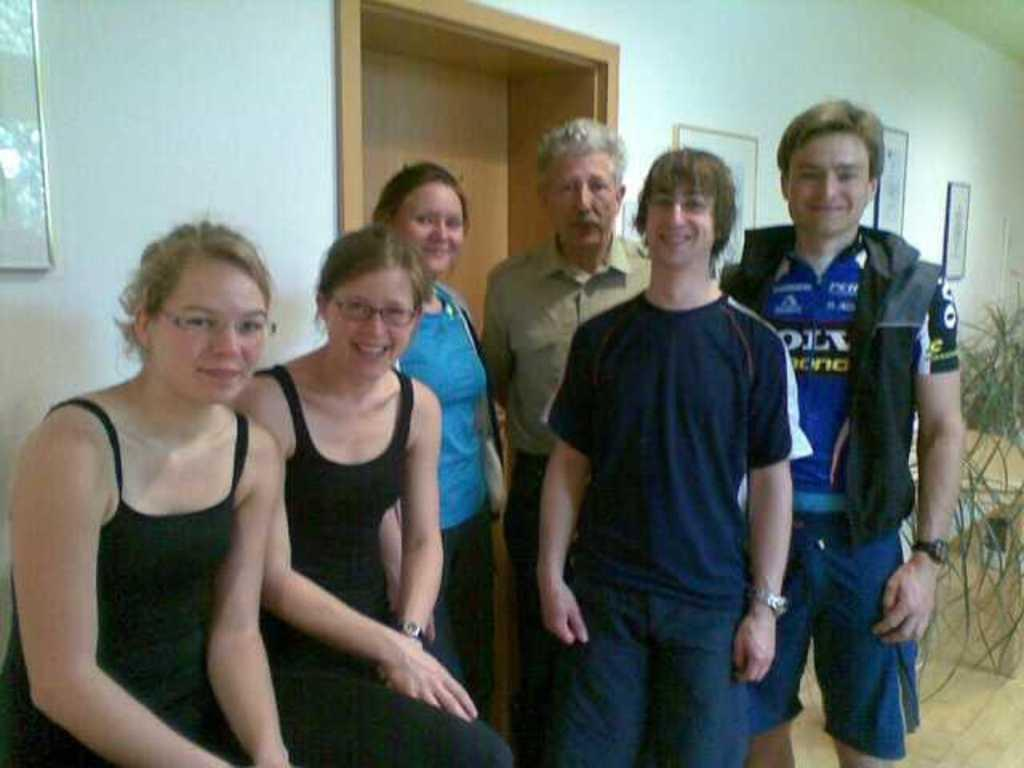How many people are present in the image? There are two people sitting and some people standing in the image. What can be seen on the wall in the background of the image? There are frames on the wall in the background of the image. What type of expert advice can be heard from the jar in the image? There is no jar present in the image, and therefore no expert advice can be heard from it. 